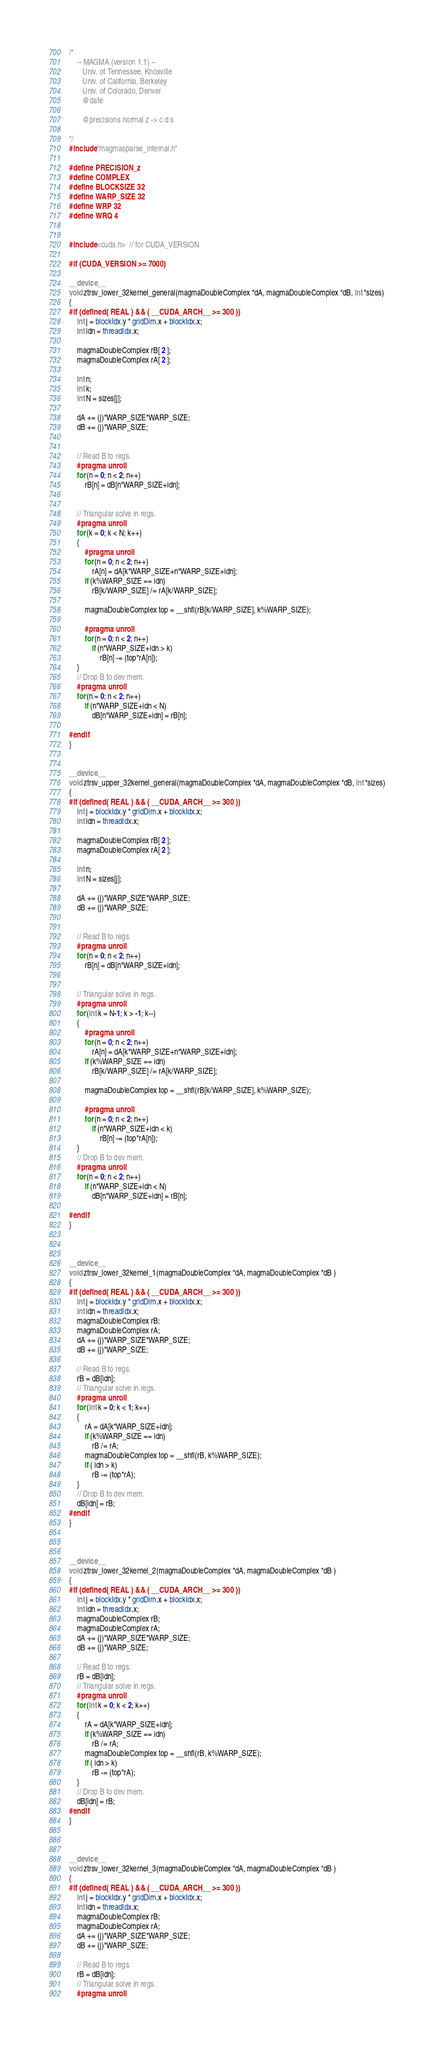<code> <loc_0><loc_0><loc_500><loc_500><_Cuda_>/*
    -- MAGMA (version 1.1) --
       Univ. of Tennessee, Knoxville
       Univ. of California, Berkeley
       Univ. of Colorado, Denver
       @date

       @precisions normal z -> c d s

*/
#include "magmasparse_internal.h"

#define PRECISION_z
#define COMPLEX
#define BLOCKSIZE 32
#define WARP_SIZE 32
#define WRP 32
#define WRQ 4


#include <cuda.h>  // for CUDA_VERSION

#if (CUDA_VERSION >= 7000)

__device__
void ztrsv_lower_32kernel_general(magmaDoubleComplex *dA, magmaDoubleComplex *dB, int *sizes)
{
#if (defined( REAL ) && ( __CUDA_ARCH__ >= 300 ))
    int j = blockIdx.y * gridDim.x + blockIdx.x;
    int idn = threadIdx.x;

    magmaDoubleComplex rB[ 2 ];
    magmaDoubleComplex rA[ 2 ];

    int n;
    int k;
    int N = sizes[j];

    dA += (j)*WARP_SIZE*WARP_SIZE;
    dB += (j)*WARP_SIZE;


    // Read B to regs.
    #pragma unroll
    for (n = 0; n < 2; n++)
        rB[n] = dB[n*WARP_SIZE+idn];


    // Triangular solve in regs.
    #pragma unroll
    for (k = 0; k < N; k++)
    {
        #pragma unroll
        for (n = 0; n < 2; n++)
            rA[n] = dA[k*WARP_SIZE+n*WARP_SIZE+idn];
        if (k%WARP_SIZE == idn)
            rB[k/WARP_SIZE] /= rA[k/WARP_SIZE];

        magmaDoubleComplex top = __shfl(rB[k/WARP_SIZE], k%WARP_SIZE);

        #pragma unroll
        for (n = 0; n < 2; n++)
            if (n*WARP_SIZE+idn > k)
                rB[n] -= (top*rA[n]);
    }
    // Drop B to dev mem.
    #pragma unroll
    for (n = 0; n < 2; n++)
        if (n*WARP_SIZE+idn < N)
            dB[n*WARP_SIZE+idn] = rB[n];

#endif
}


__device__
void ztrsv_upper_32kernel_general(magmaDoubleComplex *dA, magmaDoubleComplex *dB, int *sizes)
{
#if (defined( REAL ) && ( __CUDA_ARCH__ >= 300 ))
    int j = blockIdx.y * gridDim.x + blockIdx.x;
    int idn = threadIdx.x;

    magmaDoubleComplex rB[ 2 ];
    magmaDoubleComplex rA[ 2 ];

    int n;
    int N = sizes[j];

    dA += (j)*WARP_SIZE*WARP_SIZE;
    dB += (j)*WARP_SIZE;


    // Read B to regs.
    #pragma unroll
    for (n = 0; n < 2; n++)
        rB[n] = dB[n*WARP_SIZE+idn];


    // Triangular solve in regs.
    #pragma unroll
    for (int k = N-1; k > -1; k--)
    {
        #pragma unroll
        for (n = 0; n < 2; n++)
            rA[n] = dA[k*WARP_SIZE+n*WARP_SIZE+idn];
        if (k%WARP_SIZE == idn)
            rB[k/WARP_SIZE] /= rA[k/WARP_SIZE];

        magmaDoubleComplex top = __shfl(rB[k/WARP_SIZE], k%WARP_SIZE);

        #pragma unroll
        for (n = 0; n < 2; n++)
            if (n*WARP_SIZE+idn < k)
                rB[n] -= (top*rA[n]);
    }
    // Drop B to dev mem.
    #pragma unroll
    for (n = 0; n < 2; n++)
        if (n*WARP_SIZE+idn < N)
            dB[n*WARP_SIZE+idn] = rB[n];

#endif
}



__device__
void ztrsv_lower_32kernel_1(magmaDoubleComplex *dA, magmaDoubleComplex *dB )
{
#if (defined( REAL ) && ( __CUDA_ARCH__ >= 300 ))
    int j = blockIdx.y * gridDim.x + blockIdx.x;
    int idn = threadIdx.x;
    magmaDoubleComplex rB;
    magmaDoubleComplex rA;
    dA += (j)*WARP_SIZE*WARP_SIZE;
    dB += (j)*WARP_SIZE;

    // Read B to regs.
    rB = dB[idn];
    // Triangular solve in regs.
    #pragma unroll
    for (int k = 0; k < 1; k++)
    {
        rA = dA[k*WARP_SIZE+idn];
        if (k%WARP_SIZE == idn)
            rB /= rA;
        magmaDoubleComplex top = __shfl(rB, k%WARP_SIZE);
        if ( idn > k)
            rB -= (top*rA);
    }
    // Drop B to dev mem.
    dB[idn] = rB;
#endif
}



__device__
void ztrsv_lower_32kernel_2(magmaDoubleComplex *dA, magmaDoubleComplex *dB )
{
#if (defined( REAL ) && ( __CUDA_ARCH__ >= 300 ))
    int j = blockIdx.y * gridDim.x + blockIdx.x;
    int idn = threadIdx.x;
    magmaDoubleComplex rB;
    magmaDoubleComplex rA;
    dA += (j)*WARP_SIZE*WARP_SIZE;
    dB += (j)*WARP_SIZE;

    // Read B to regs.
    rB = dB[idn];
    // Triangular solve in regs.
    #pragma unroll
    for (int k = 0; k < 2; k++)
    {
        rA = dA[k*WARP_SIZE+idn];
        if (k%WARP_SIZE == idn)
            rB /= rA;
        magmaDoubleComplex top = __shfl(rB, k%WARP_SIZE);
        if ( idn > k)
            rB -= (top*rA);
    }
    // Drop B to dev mem.
    dB[idn] = rB;
#endif
}



__device__
void ztrsv_lower_32kernel_3(magmaDoubleComplex *dA, magmaDoubleComplex *dB )
{
#if (defined( REAL ) && ( __CUDA_ARCH__ >= 300 ))
    int j = blockIdx.y * gridDim.x + blockIdx.x;
    int idn = threadIdx.x;
    magmaDoubleComplex rB;
    magmaDoubleComplex rA;
    dA += (j)*WARP_SIZE*WARP_SIZE;
    dB += (j)*WARP_SIZE;

    // Read B to regs.
    rB = dB[idn];
    // Triangular solve in regs.
    #pragma unroll</code> 